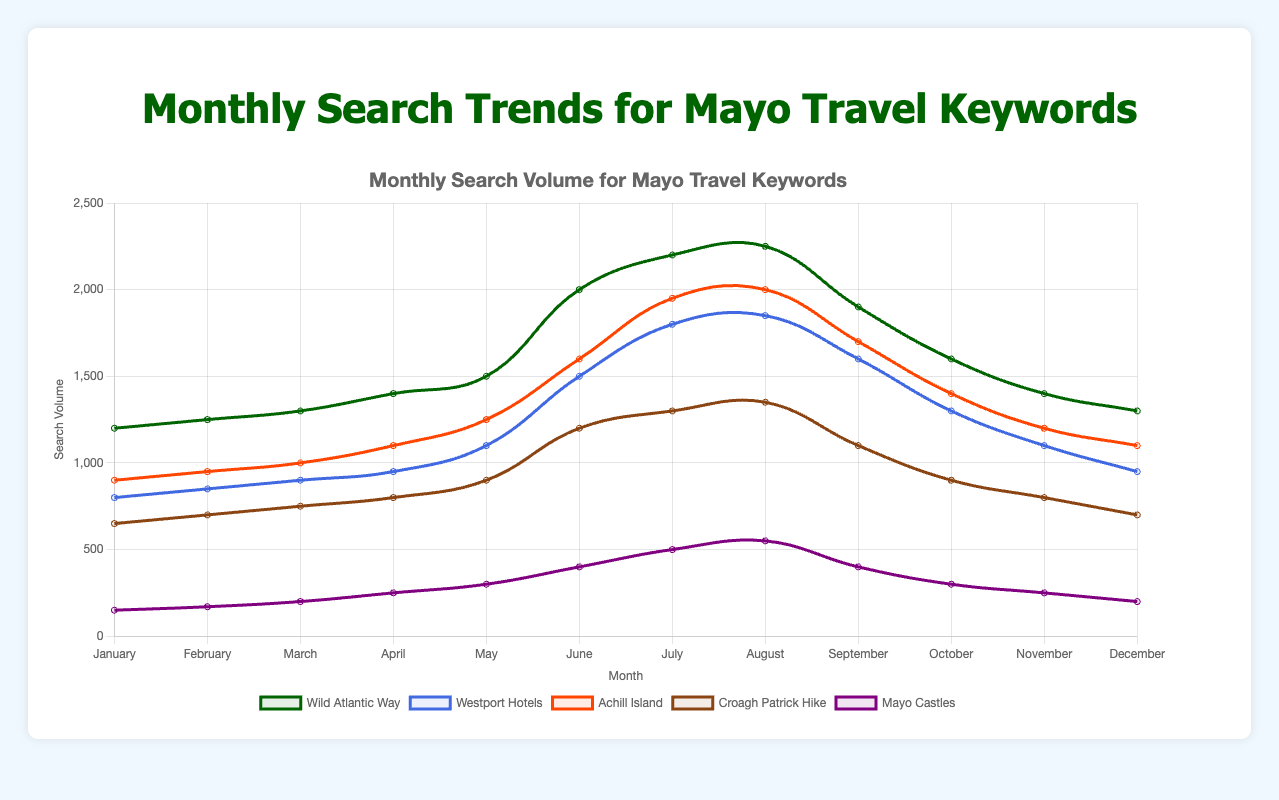What is the total search volume in June for all keywords combined? Sum the search volumes for all keywords in June: Wild Atlantic Way (2000) + Westport Hotels (1500) + Achill Island (1600) + Croagh Patrick Hike (1200) + Mayo Castles (400), which equals 6700
Answer: 6700 Which keyword experienced the highest search volume in August? Look at the dataset for August and compare the search volumes: Wild Atlantic Way (2250), Westport Hotels (1850), Achill Island (2000), Croagh Patrick Hike (1350), Mayo Castles (550). The highest volume is 2250 for Wild Atlantic Way
Answer: Wild Atlantic Way How does the search volume for Croagh Patrick Hike in September compare to that in March? Compare the search volumes: September (1100) vs. March (750). Subtract March from September: 1100 - 750 = 350
Answer: 350 higher Which keyword saw the lowest search volume in January? Look at the dataset for January and compare search volumes: Wild Atlantic Way (1200), Westport Hotels (800), Achill Island (900), Croagh Patrick Hike (650), Mayo Castles (150). The lowest volume is 150 for Mayo Castles
Answer: Mayo Castles What was the average monthly search volume for Achill Island? Sum the monthly search volumes for the year and divide by 12: (900 + 950 + 1000 + 1100 + 1250 + 1600 + 1950 + 2000 + 1700 + 1400 + 1200 + 1100) = 16150, then divide by 12, which equals approximately 1346
Answer: 1346 Which month had the largest increase in search volume for the Wild Atlantic Way? Compare month-to-month differences, find the largest increase: January (1200), February (1250), March (1300), April (1400), May (1500), June (2000), July (2200), August (2250), September (1900), October (1600), November (1400), December (1300). The largest increase is from May (1500) to June (2000): 2000 - 1500 = 500
Answer: June Among the keywords, which one had the most consistent search volume throughout the year? Evaluate the fluctuations in search volumes across the months for each keyword: Wild Atlantic Way, Westport Hotels, Achill Island, Croagh Patrick Hike, Mayo Castles. Croagh Patrick Hike has the most consistent range, from 650 to 1350
Answer: Croagh Patrick Hike In what month did Mayo Castles see the highest search volume and what was it? Find the highest search volume for Mayo Castles across all months. The highest is 550 in August
Answer: August, 550 How does the search volume for Westport Hotels in December compare to its volume in May? Compare the search volumes: December (950) vs. May (1100). Subtract December from May: 1100 - 950 = 150
Answer: 150 lower What trend can you observe in the search volume for Croagh Patrick Hike from January to December? Observe the monthly search volumes: January (650), February (700), March (750), April (800), May (900), June (1200), July (1300), August (1350), September (1100), October (900), November (800), December (700). Croagh Patrick Hike increases steadily until August and then decreases towards December
Answer: Increases until August, then decreases 